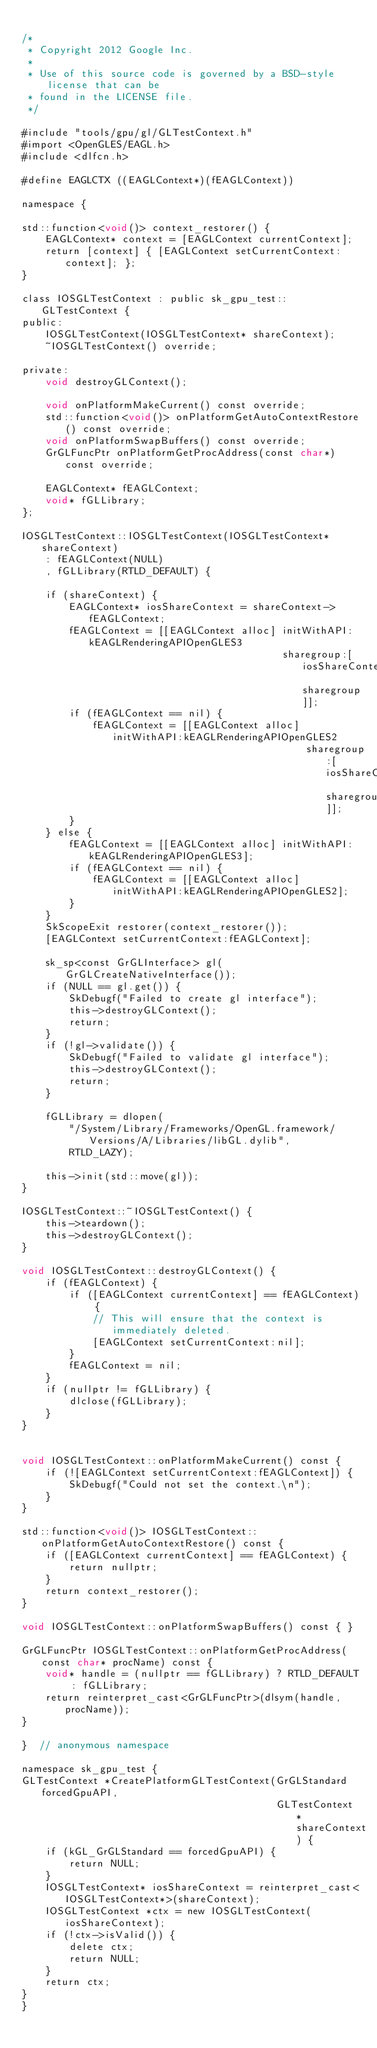<code> <loc_0><loc_0><loc_500><loc_500><_ObjectiveC_>
/*
 * Copyright 2012 Google Inc.
 *
 * Use of this source code is governed by a BSD-style license that can be
 * found in the LICENSE file.
 */

#include "tools/gpu/gl/GLTestContext.h"
#import <OpenGLES/EAGL.h>
#include <dlfcn.h>

#define EAGLCTX ((EAGLContext*)(fEAGLContext))

namespace {

std::function<void()> context_restorer() {
    EAGLContext* context = [EAGLContext currentContext];
    return [context] { [EAGLContext setCurrentContext:context]; };
}

class IOSGLTestContext : public sk_gpu_test::GLTestContext {
public:
    IOSGLTestContext(IOSGLTestContext* shareContext);
    ~IOSGLTestContext() override;

private:
    void destroyGLContext();

    void onPlatformMakeCurrent() const override;
    std::function<void()> onPlatformGetAutoContextRestore() const override;
    void onPlatformSwapBuffers() const override;
    GrGLFuncPtr onPlatformGetProcAddress(const char*) const override;

    EAGLContext* fEAGLContext;
    void* fGLLibrary;
};

IOSGLTestContext::IOSGLTestContext(IOSGLTestContext* shareContext)
    : fEAGLContext(NULL)
    , fGLLibrary(RTLD_DEFAULT) {

    if (shareContext) {
        EAGLContext* iosShareContext = shareContext->fEAGLContext;
        fEAGLContext = [[EAGLContext alloc] initWithAPI:kEAGLRenderingAPIOpenGLES3
                                            sharegroup:[iosShareContext sharegroup]];
        if (fEAGLContext == nil) {
            fEAGLContext = [[EAGLContext alloc] initWithAPI:kEAGLRenderingAPIOpenGLES2
                                                sharegroup:[iosShareContext sharegroup]];
        }
    } else {
        fEAGLContext = [[EAGLContext alloc] initWithAPI:kEAGLRenderingAPIOpenGLES3];
        if (fEAGLContext == nil) {
            fEAGLContext = [[EAGLContext alloc] initWithAPI:kEAGLRenderingAPIOpenGLES2];
        }
    }
    SkScopeExit restorer(context_restorer());
    [EAGLContext setCurrentContext:fEAGLContext];

    sk_sp<const GrGLInterface> gl(GrGLCreateNativeInterface());
    if (NULL == gl.get()) {
        SkDebugf("Failed to create gl interface");
        this->destroyGLContext();
        return;
    }
    if (!gl->validate()) {
        SkDebugf("Failed to validate gl interface");
        this->destroyGLContext();
        return;
    }

    fGLLibrary = dlopen(
        "/System/Library/Frameworks/OpenGL.framework/Versions/A/Libraries/libGL.dylib",
        RTLD_LAZY);

    this->init(std::move(gl));
}

IOSGLTestContext::~IOSGLTestContext() {
    this->teardown();
    this->destroyGLContext();
}

void IOSGLTestContext::destroyGLContext() {
    if (fEAGLContext) {
        if ([EAGLContext currentContext] == fEAGLContext) {
            // This will ensure that the context is immediately deleted.
            [EAGLContext setCurrentContext:nil];
        }
        fEAGLContext = nil;
    }
    if (nullptr != fGLLibrary) {
        dlclose(fGLLibrary);
    }
}


void IOSGLTestContext::onPlatformMakeCurrent() const {
    if (![EAGLContext setCurrentContext:fEAGLContext]) {
        SkDebugf("Could not set the context.\n");
    }
}

std::function<void()> IOSGLTestContext::onPlatformGetAutoContextRestore() const {
    if ([EAGLContext currentContext] == fEAGLContext) {
		return nullptr;
	}
    return context_restorer();
}

void IOSGLTestContext::onPlatformSwapBuffers() const { }

GrGLFuncPtr IOSGLTestContext::onPlatformGetProcAddress(const char* procName) const {
    void* handle = (nullptr == fGLLibrary) ? RTLD_DEFAULT : fGLLibrary;
    return reinterpret_cast<GrGLFuncPtr>(dlsym(handle, procName));
}

}  // anonymous namespace

namespace sk_gpu_test {
GLTestContext *CreatePlatformGLTestContext(GrGLStandard forcedGpuAPI,
                                           GLTestContext *shareContext) {
    if (kGL_GrGLStandard == forcedGpuAPI) {
        return NULL;
    }
    IOSGLTestContext* iosShareContext = reinterpret_cast<IOSGLTestContext*>(shareContext);
    IOSGLTestContext *ctx = new IOSGLTestContext(iosShareContext);
    if (!ctx->isValid()) {
        delete ctx;
        return NULL;
    }
    return ctx;
}
}
</code> 